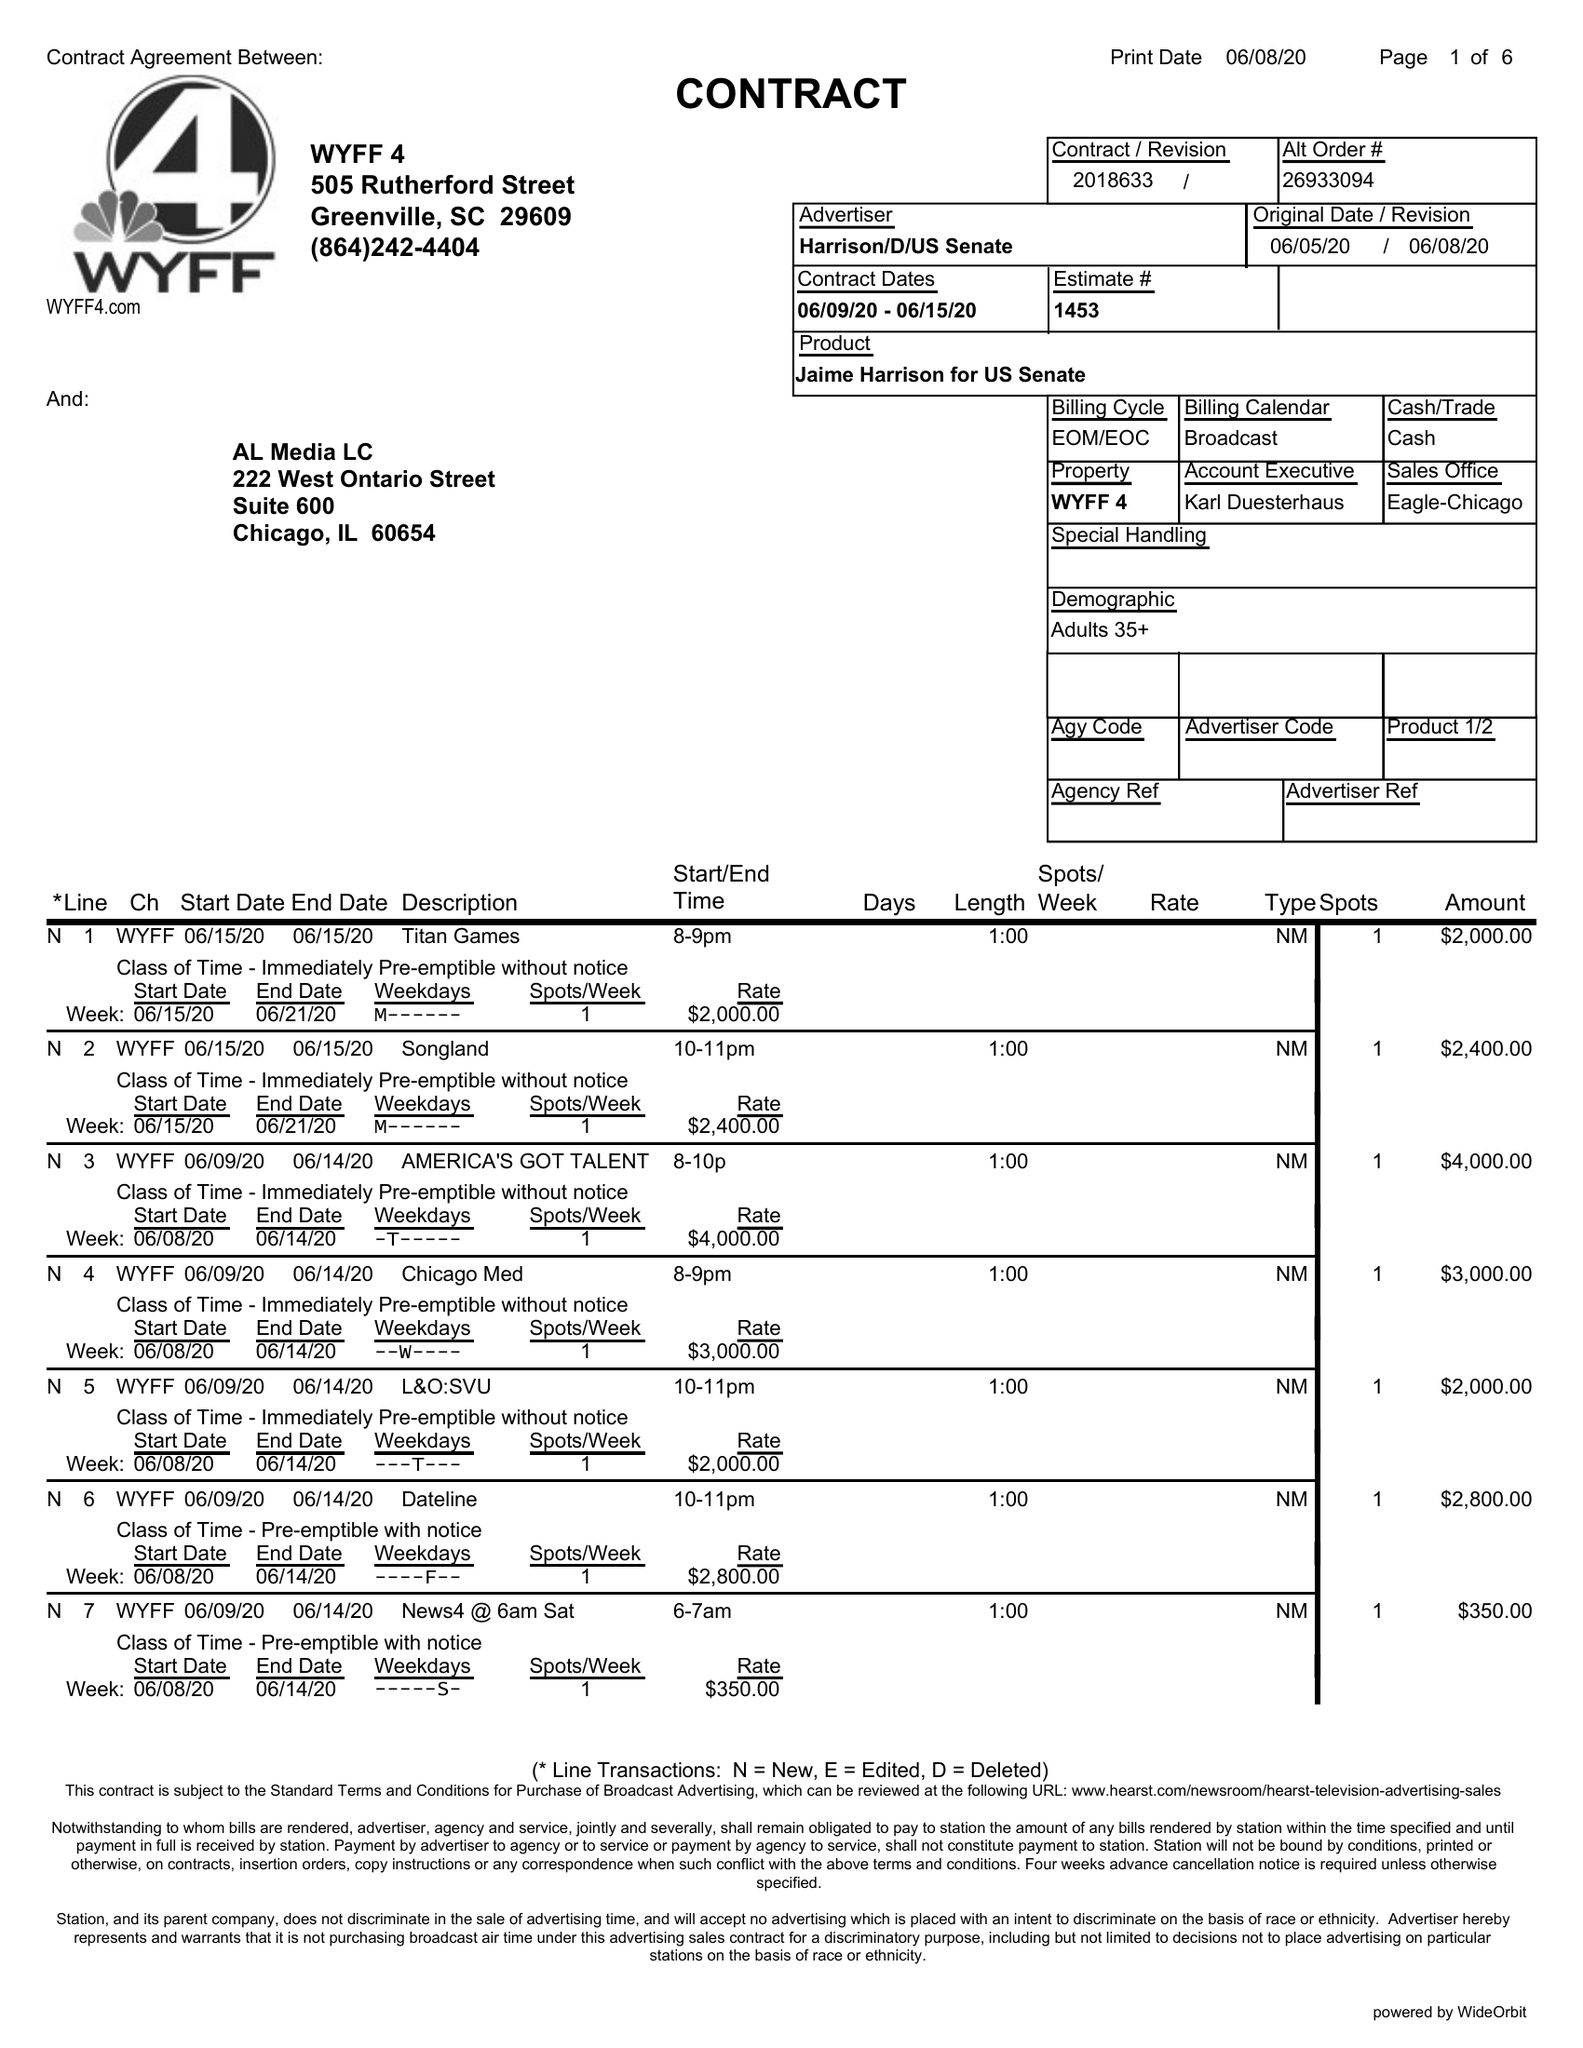What is the value for the advertiser?
Answer the question using a single word or phrase. HARRISON/D/USSENATE 